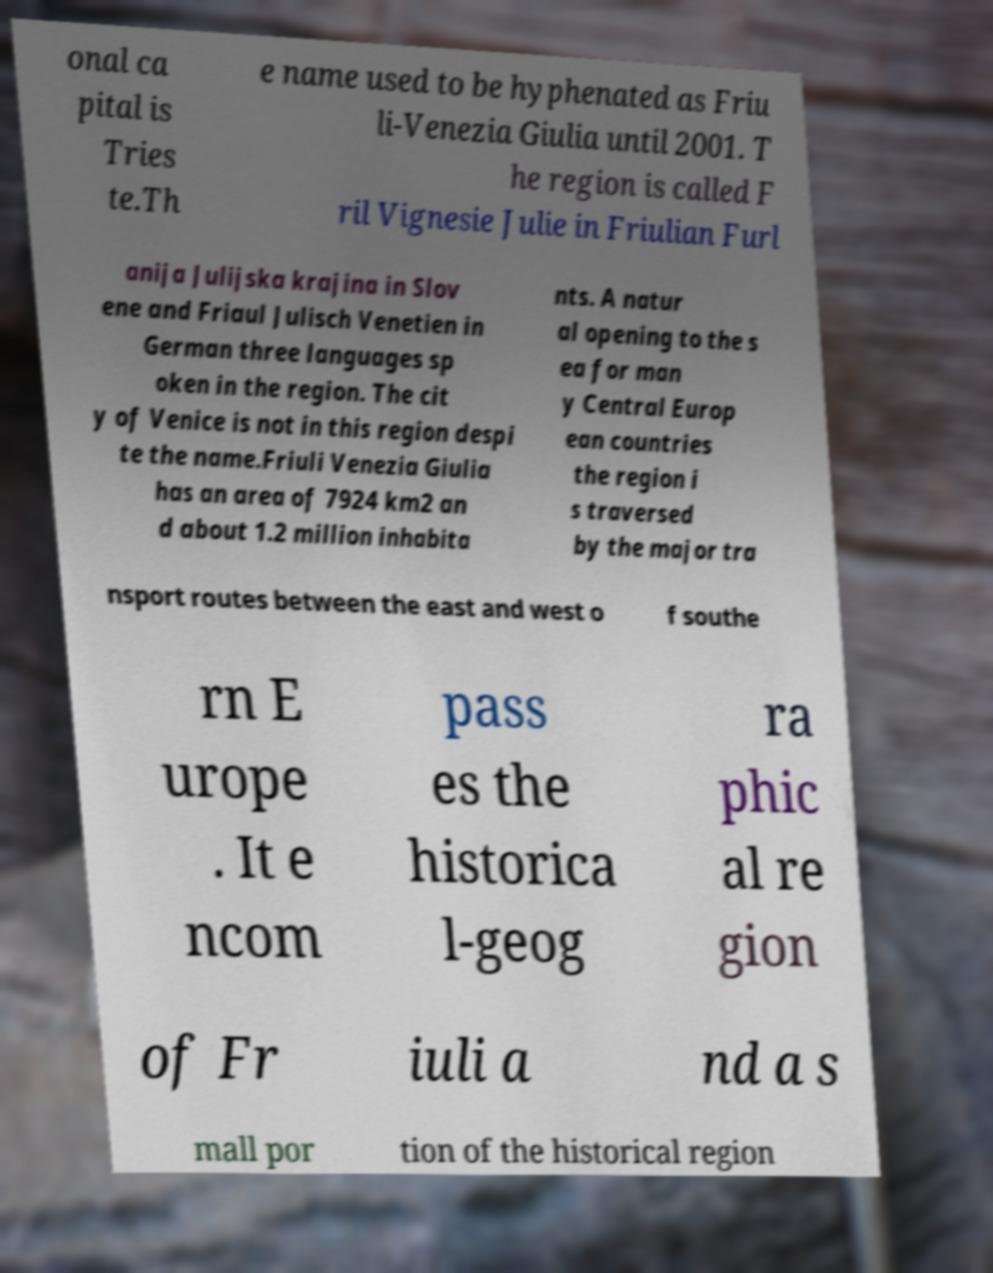Can you read and provide the text displayed in the image?This photo seems to have some interesting text. Can you extract and type it out for me? onal ca pital is Tries te.Th e name used to be hyphenated as Friu li-Venezia Giulia until 2001. T he region is called F ril Vignesie Julie in Friulian Furl anija Julijska krajina in Slov ene and Friaul Julisch Venetien in German three languages sp oken in the region. The cit y of Venice is not in this region despi te the name.Friuli Venezia Giulia has an area of 7924 km2 an d about 1.2 million inhabita nts. A natur al opening to the s ea for man y Central Europ ean countries the region i s traversed by the major tra nsport routes between the east and west o f southe rn E urope . It e ncom pass es the historica l-geog ra phic al re gion of Fr iuli a nd a s mall por tion of the historical region 